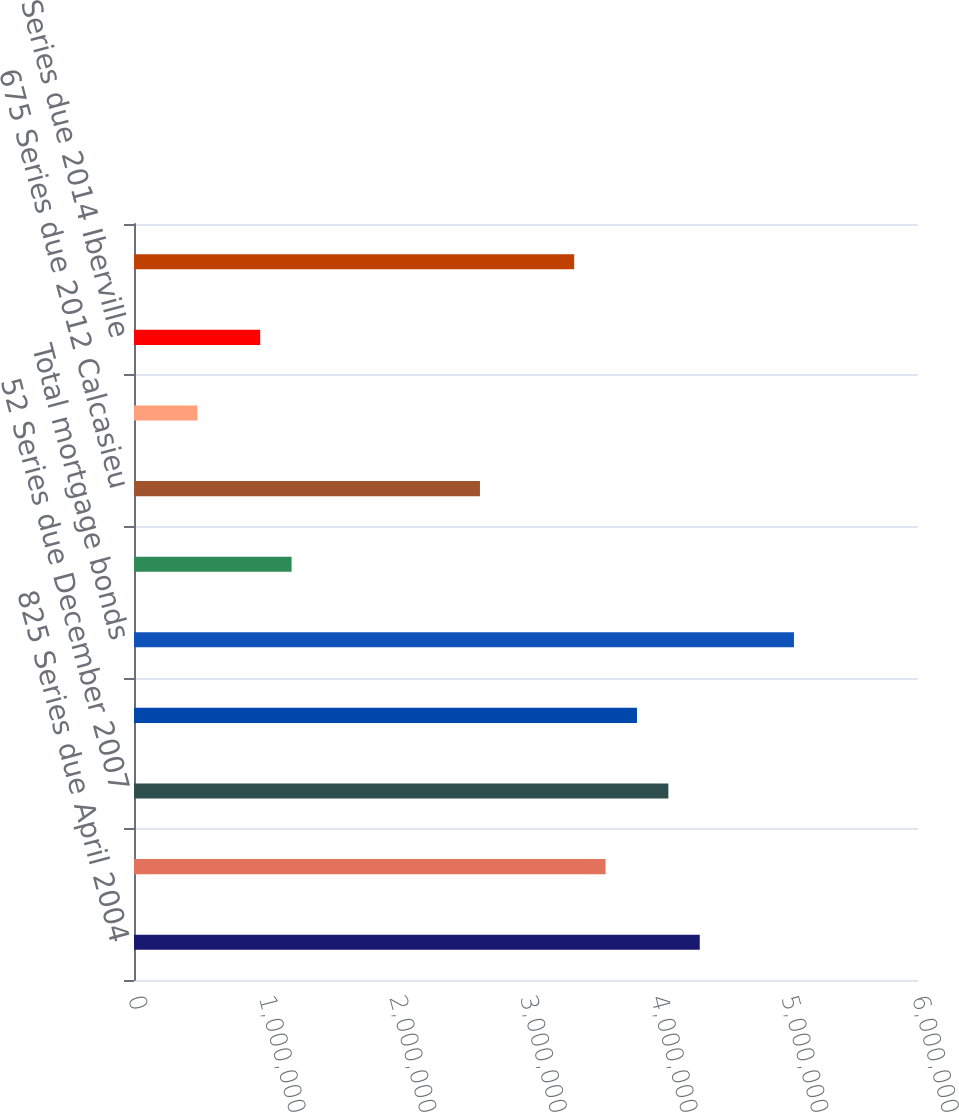Convert chart to OTSL. <chart><loc_0><loc_0><loc_500><loc_500><bar_chart><fcel>825 Series due April 2004<fcel>677 Series due August 2005<fcel>52 Series due December 2007<fcel>60 Series due December 2012<fcel>Total mortgage bonds<fcel>545 Series due 2010 Calcasieu<fcel>675 Series due 2012 Calcasieu<fcel>67 Series due 2013 Pointe<fcel>57 Series due 2014 Iberville<fcel>77 Series due 2014 West<nl><fcel>4.3298e+06<fcel>3.60891e+06<fcel>4.0895e+06<fcel>3.84921e+06<fcel>5.05069e+06<fcel>1.20594e+06<fcel>2.64772e+06<fcel>485056<fcel>965649<fcel>3.36861e+06<nl></chart> 